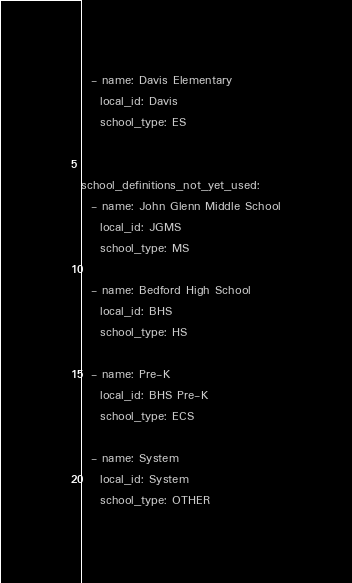Convert code to text. <code><loc_0><loc_0><loc_500><loc_500><_YAML_>  - name: Davis Elementary
    local_id: Davis
    school_type: ES

  
school_definitions_not_yet_used:
  - name: John Glenn Middle School
    local_id: JGMS
    school_type: MS
  
  - name: Bedford High School
    local_id: BHS
    school_type: HS
  
  - name: Pre-K
    local_id: BHS Pre-K
    school_type: ECS
  
  - name: System
    local_id: System
    school_type: OTHER
</code> 